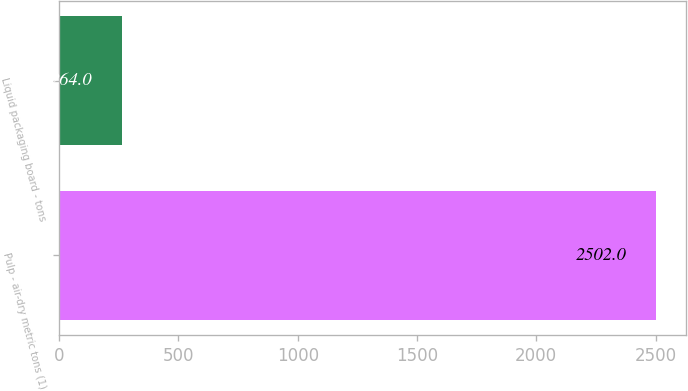Convert chart to OTSL. <chart><loc_0><loc_0><loc_500><loc_500><bar_chart><fcel>Pulp - air-dry metric tons (1)<fcel>Liquid packaging board - tons<nl><fcel>2502<fcel>264<nl></chart> 